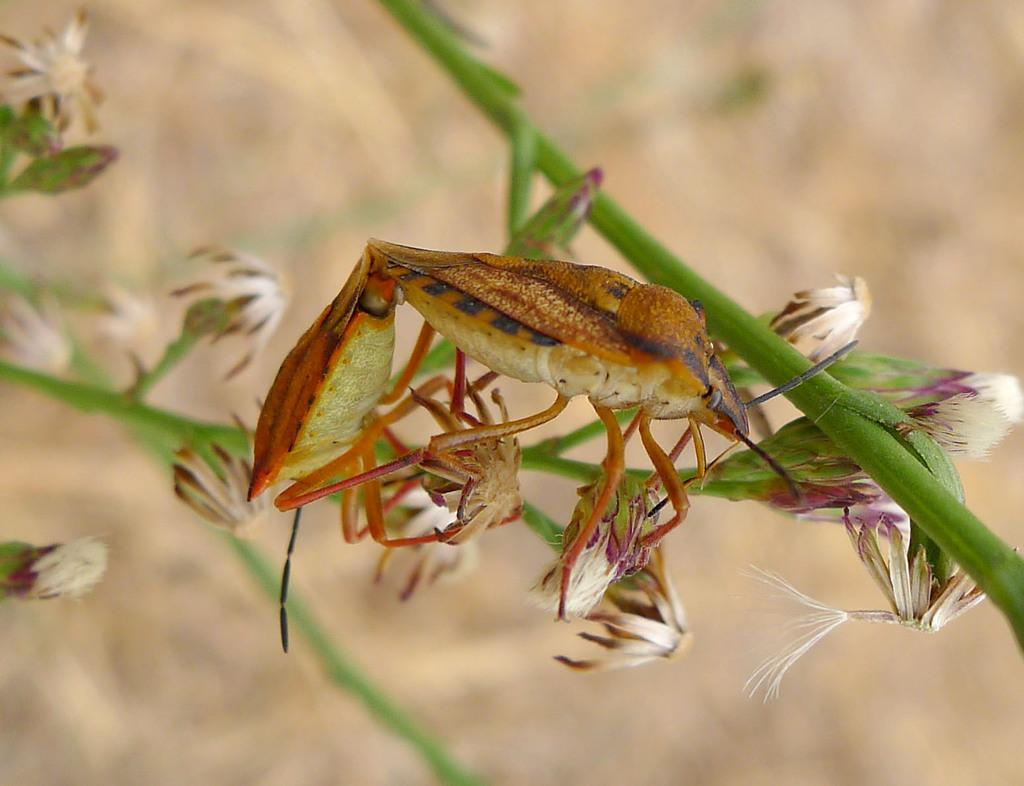What is located on the tree branch in the image? There is an insect on a tree branch in the image. What other elements can be seen in the image? There are flowers in the image. Can you describe the background of the image? The background of the image is blurry. What type of oil is being used to stop the insect from moving in the image? There is no oil or attempt to stop the insect's movement in the image; it is simply perched on a tree branch. 